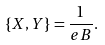<formula> <loc_0><loc_0><loc_500><loc_500>\{ X , Y \} = \frac { 1 } { e B } .</formula> 